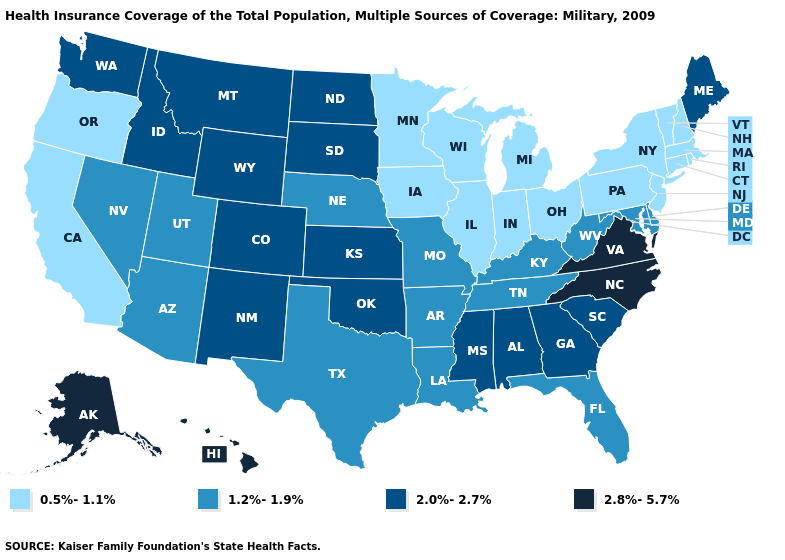Name the states that have a value in the range 0.5%-1.1%?
Give a very brief answer. California, Connecticut, Illinois, Indiana, Iowa, Massachusetts, Michigan, Minnesota, New Hampshire, New Jersey, New York, Ohio, Oregon, Pennsylvania, Rhode Island, Vermont, Wisconsin. Name the states that have a value in the range 1.2%-1.9%?
Give a very brief answer. Arizona, Arkansas, Delaware, Florida, Kentucky, Louisiana, Maryland, Missouri, Nebraska, Nevada, Tennessee, Texas, Utah, West Virginia. Does Colorado have the same value as Alaska?
Concise answer only. No. Among the states that border Arkansas , which have the lowest value?
Concise answer only. Louisiana, Missouri, Tennessee, Texas. Among the states that border Kentucky , which have the highest value?
Short answer required. Virginia. What is the highest value in the USA?
Answer briefly. 2.8%-5.7%. What is the value of Alaska?
Be succinct. 2.8%-5.7%. Does the first symbol in the legend represent the smallest category?
Be succinct. Yes. Name the states that have a value in the range 1.2%-1.9%?
Give a very brief answer. Arizona, Arkansas, Delaware, Florida, Kentucky, Louisiana, Maryland, Missouri, Nebraska, Nevada, Tennessee, Texas, Utah, West Virginia. Among the states that border Maine , which have the lowest value?
Be succinct. New Hampshire. What is the value of Virginia?
Answer briefly. 2.8%-5.7%. Does the map have missing data?
Quick response, please. No. What is the value of Utah?
Be succinct. 1.2%-1.9%. Name the states that have a value in the range 0.5%-1.1%?
Short answer required. California, Connecticut, Illinois, Indiana, Iowa, Massachusetts, Michigan, Minnesota, New Hampshire, New Jersey, New York, Ohio, Oregon, Pennsylvania, Rhode Island, Vermont, Wisconsin. What is the highest value in states that border Utah?
Short answer required. 2.0%-2.7%. 